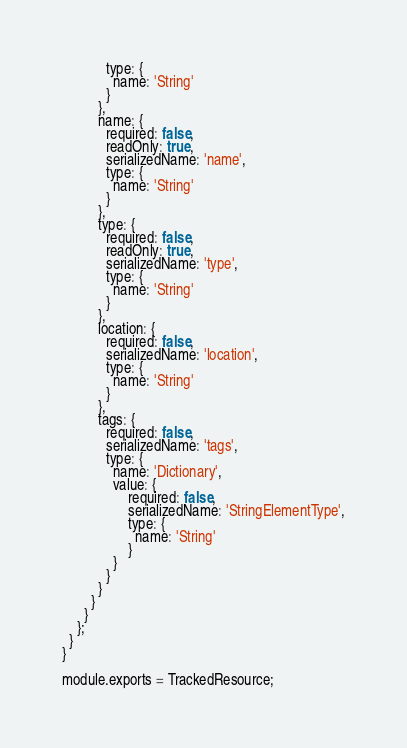<code> <loc_0><loc_0><loc_500><loc_500><_JavaScript_>            type: {
              name: 'String'
            }
          },
          name: {
            required: false,
            readOnly: true,
            serializedName: 'name',
            type: {
              name: 'String'
            }
          },
          type: {
            required: false,
            readOnly: true,
            serializedName: 'type',
            type: {
              name: 'String'
            }
          },
          location: {
            required: false,
            serializedName: 'location',
            type: {
              name: 'String'
            }
          },
          tags: {
            required: false,
            serializedName: 'tags',
            type: {
              name: 'Dictionary',
              value: {
                  required: false,
                  serializedName: 'StringElementType',
                  type: {
                    name: 'String'
                  }
              }
            }
          }
        }
      }
    };
  }
}

module.exports = TrackedResource;
</code> 